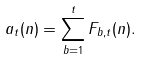<formula> <loc_0><loc_0><loc_500><loc_500>a _ { t } ( n ) = \sum _ { b = 1 } ^ { t } F _ { b , t } ( n ) .</formula> 